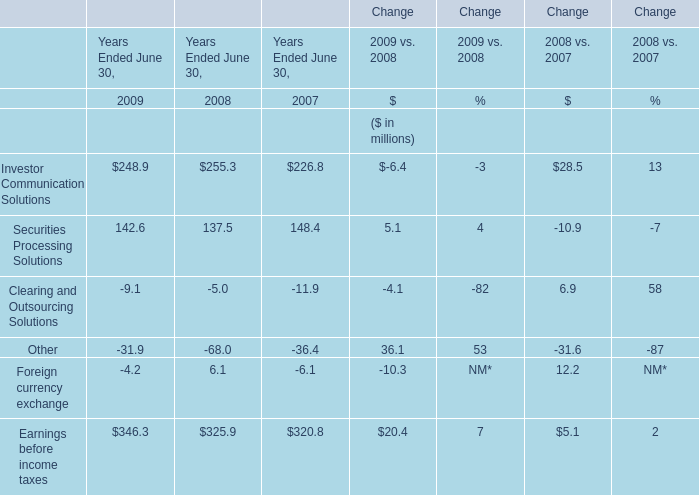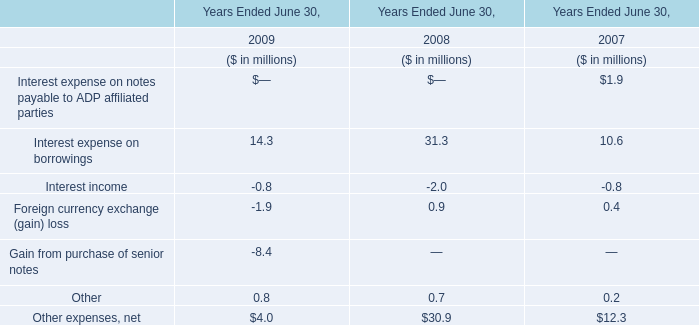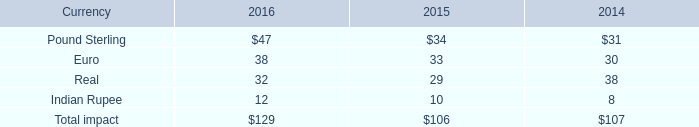What will Securities Processing Solutions be like in 2010 if it continues to grow at the same rate as it did in 2009? (in million) 
Computations: (142.6 * (1 + 0.04))
Answer: 148.304. 